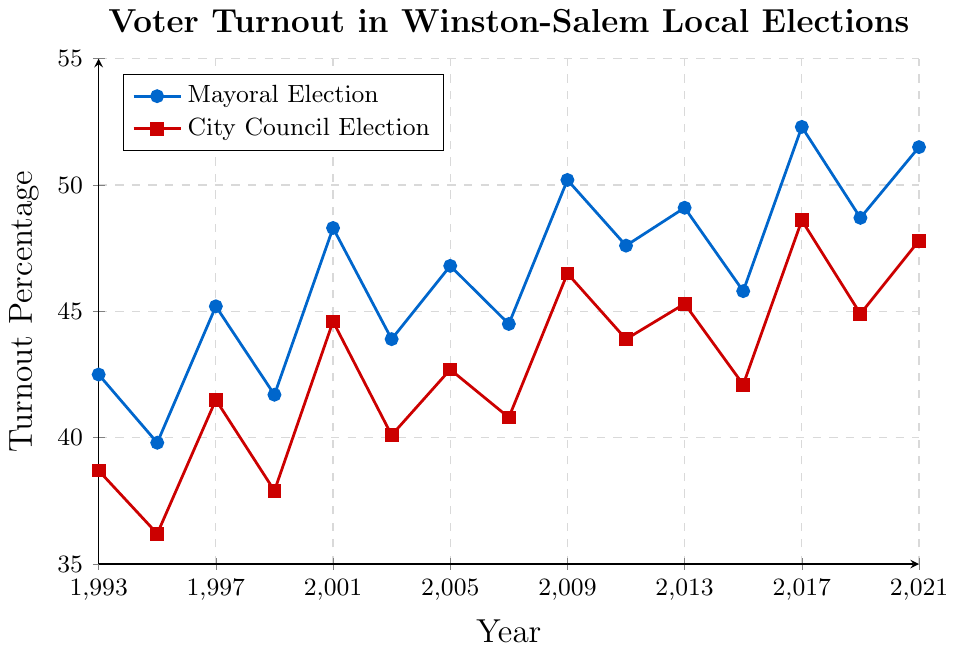What year had the highest mayoral election turnout? First, look for the peak in the blue line representing mayoral elections. The highest point is in 2017 with a turnout of 52.3%.
Answer: 2017 Which election type had a higher turnout in 2009, and by how much? Compare the blue line (mayoral election) and the red line (city council election) in 2009. The mayoral turnout is 50.2%, and the city council turnout is 46.5%. Subtract 46.5 from 50.2 to get the difference of 3.7%.
Answer: Mayoral by 3.7% What is the general trend in voter turnout for mayoral elections over the years? Observe the blue line from 1993 to 2021. The turnout generally fluctuates but shows an increasing trend overall, especially noticeable with peaks in 2009, 2013, 2017, and 2021.
Answer: Increasing trend How did voter turnout in city council elections change from 1993 to 2021? Look at the red line from the beginning (1993) to the end (2021). It starts at 38.7% and ends at 47.8%. The overall trend shows an increase in turnout.
Answer: Increased What is the average turnout percentage for city council elections between 1993 and 2021? Add all the percentages for city council turnouts and divide by the number of years. (38.7 + 36.2 + 41.5 + 37.9 + 44.6 + 40.1 + 42.7 + 40.8 + 46.5 + 43.9 + 45.3 + 42.1 + 48.6 + 44.9 + 47.8)/15 = 43.4%.
Answer: 43.4% Between which years did the voter turnout for mayoral elections experience the sharpest increase? Identify the steepest upward segment of the blue line. From 2015 (45.8%) to 2017 (52.3%), the change is 6.5%, which is the sharpest increase.
Answer: 2015-2017 How many years did the turnout for city council elections exceed 45%? Count the years where the red line is above 45%. These are 2009, 2013, 2017, 2019, and 2021.
Answer: 5 years Which year had the largest gap between mayoral and city council election turnouts, and what was the gap? Compute the differences for each year and find the largest one. In 2017, the mayoral turnout was 52.3%, and the city council turnout was 48.6%, giving a gap of 3.7%, which is the largest.
Answer: 2017 with a gap of 3.7% What color represents the mayoral election turnout on the plot? The blue line represents the mayoral election turnout, as indicated by the legend under "Mayoral Election".
Answer: Blue Are there any years where the voter turnout for city council elections was higher than that for mayoral elections? Verify if the red line is ever above the blue line for any year. The red line does not exceed the blue line in any year shown.
Answer: No 